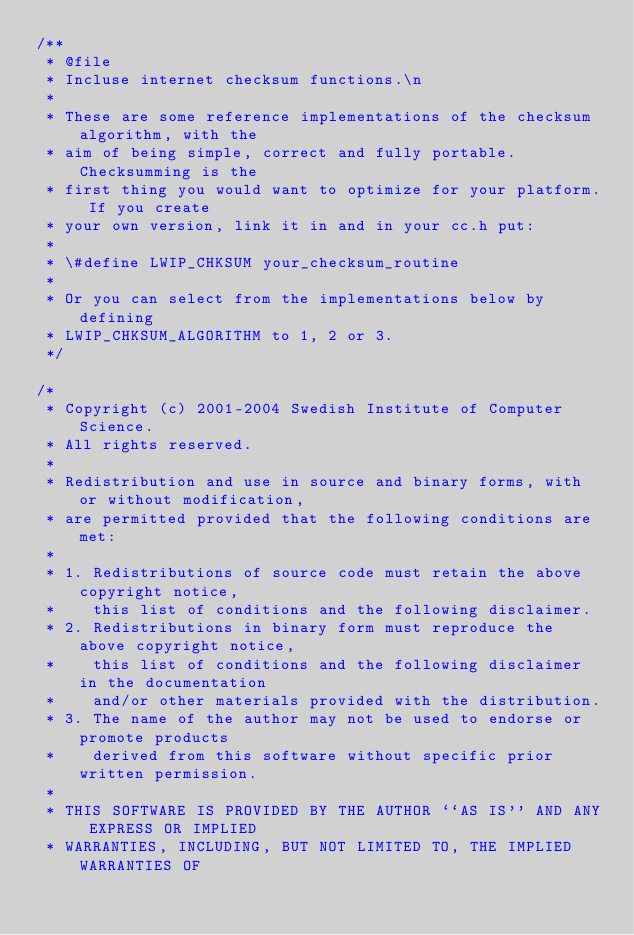<code> <loc_0><loc_0><loc_500><loc_500><_C_>/**
 * @file
 * Incluse internet checksum functions.\n
 *
 * These are some reference implementations of the checksum algorithm, with the
 * aim of being simple, correct and fully portable. Checksumming is the
 * first thing you would want to optimize for your platform. If you create
 * your own version, link it in and in your cc.h put:
 *
 * \#define LWIP_CHKSUM your_checksum_routine
 * 
 * Or you can select from the implementations below by defining
 * LWIP_CHKSUM_ALGORITHM to 1, 2 or 3.
 */

/*
 * Copyright (c) 2001-2004 Swedish Institute of Computer Science.
 * All rights reserved.
 *
 * Redistribution and use in source and binary forms, with or without modification,
 * are permitted provided that the following conditions are met:
 *
 * 1. Redistributions of source code must retain the above copyright notice,
 *    this list of conditions and the following disclaimer.
 * 2. Redistributions in binary form must reproduce the above copyright notice,
 *    this list of conditions and the following disclaimer in the documentation
 *    and/or other materials provided with the distribution.
 * 3. The name of the author may not be used to endorse or promote products
 *    derived from this software without specific prior written permission.
 *
 * THIS SOFTWARE IS PROVIDED BY THE AUTHOR ``AS IS'' AND ANY EXPRESS OR IMPLIED
 * WARRANTIES, INCLUDING, BUT NOT LIMITED TO, THE IMPLIED WARRANTIES OF</code> 